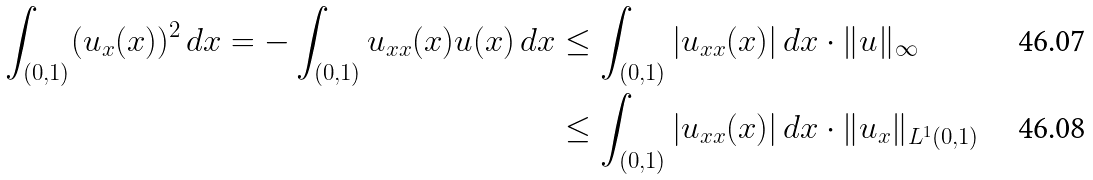Convert formula to latex. <formula><loc_0><loc_0><loc_500><loc_500>\int _ { ( 0 , 1 ) } ( u _ { x } ( x ) ) ^ { 2 } \, d x = - \int _ { ( 0 , 1 ) } u _ { x x } ( x ) u ( x ) \, d x & \leq \int _ { ( 0 , 1 ) } | u _ { x x } ( x ) | \, d x \cdot \| u \| _ { \infty } \\ & \leq \int _ { ( 0 , 1 ) } | u _ { x x } ( x ) | \, d x \cdot \| u _ { x } \| _ { L ^ { 1 } ( 0 , 1 ) }</formula> 